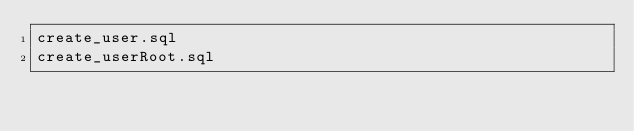Convert code to text. <code><loc_0><loc_0><loc_500><loc_500><_SQL_>create_user.sql
create_userRoot.sql</code> 